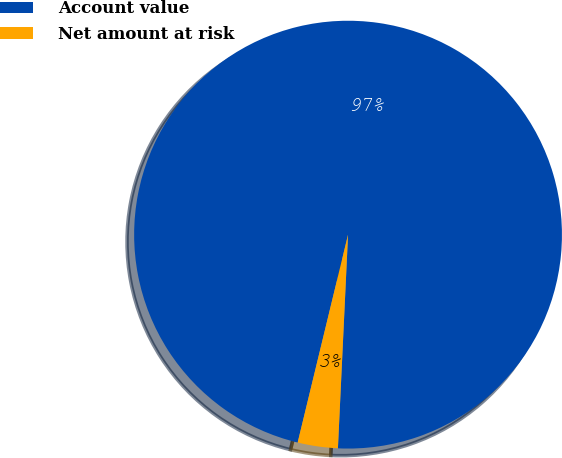<chart> <loc_0><loc_0><loc_500><loc_500><pie_chart><fcel>Account value<fcel>Net amount at risk<nl><fcel>96.97%<fcel>3.03%<nl></chart> 